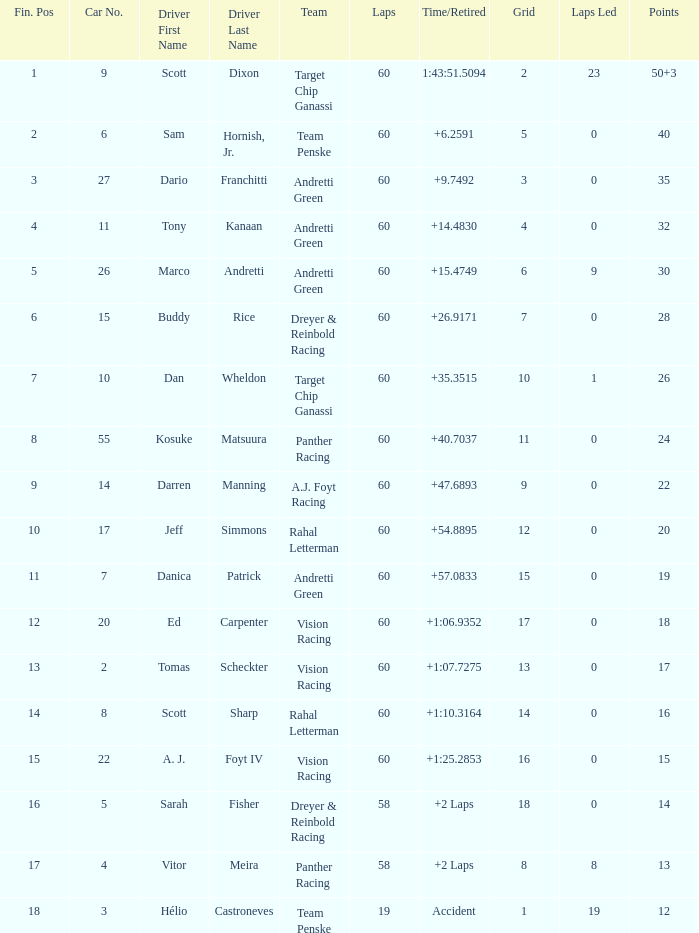Name the laps for 18 pointss 60.0. 